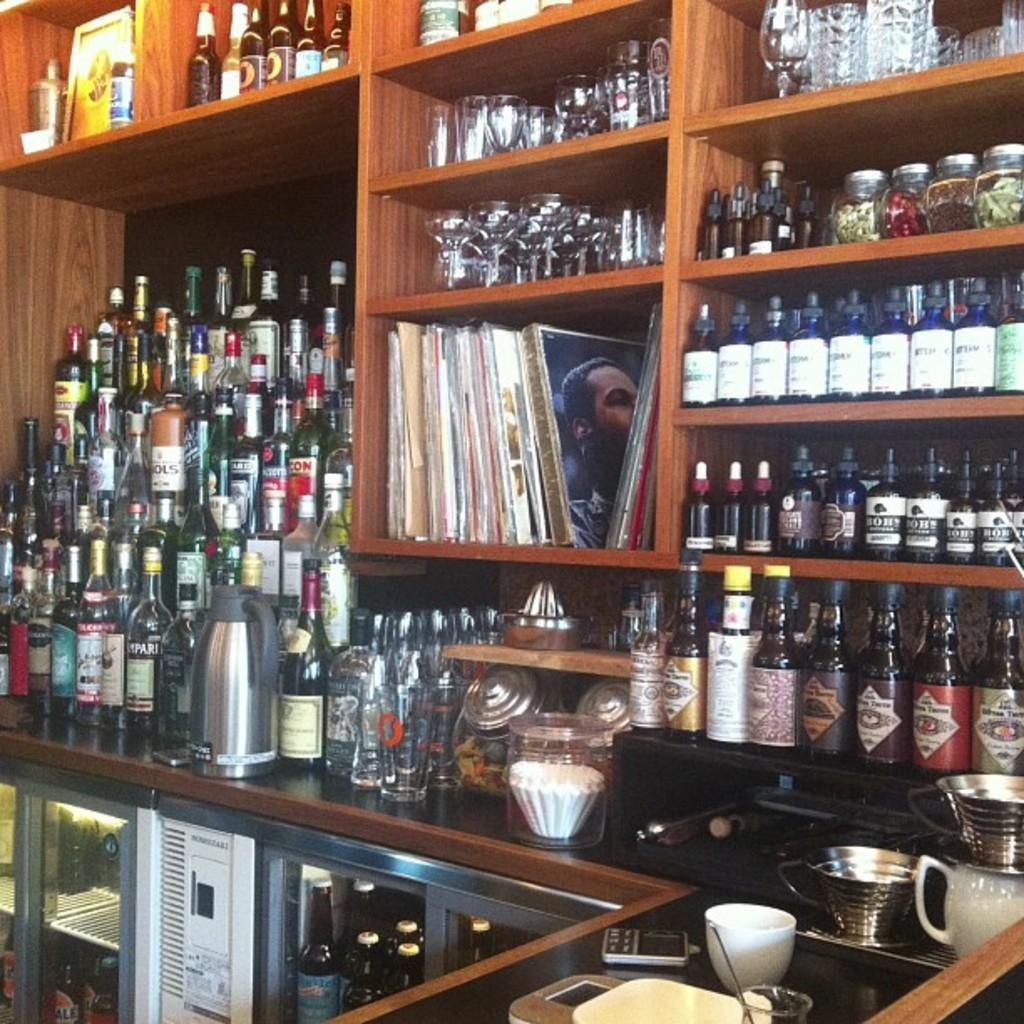What type of objects can be seen in the image? There are rocks, wine bottles, books, a desk, a cup, a jar, and glasses in the image. Where are the wine bottles located in the image? The wine bottles are in the image. What is the primary piece of furniture in the image? There is a desk in the image. What items are on the desk in the image? There is a cup, a jar, and glasses on the desk in the image. What type of animal can be seen with a tail in the image? There are no animals present in the image, and therefore no tails can be observed. What reason is given for the arrangement of the objects in the image? The provided facts do not include any information about the reason for the arrangement of the objects in the image. 